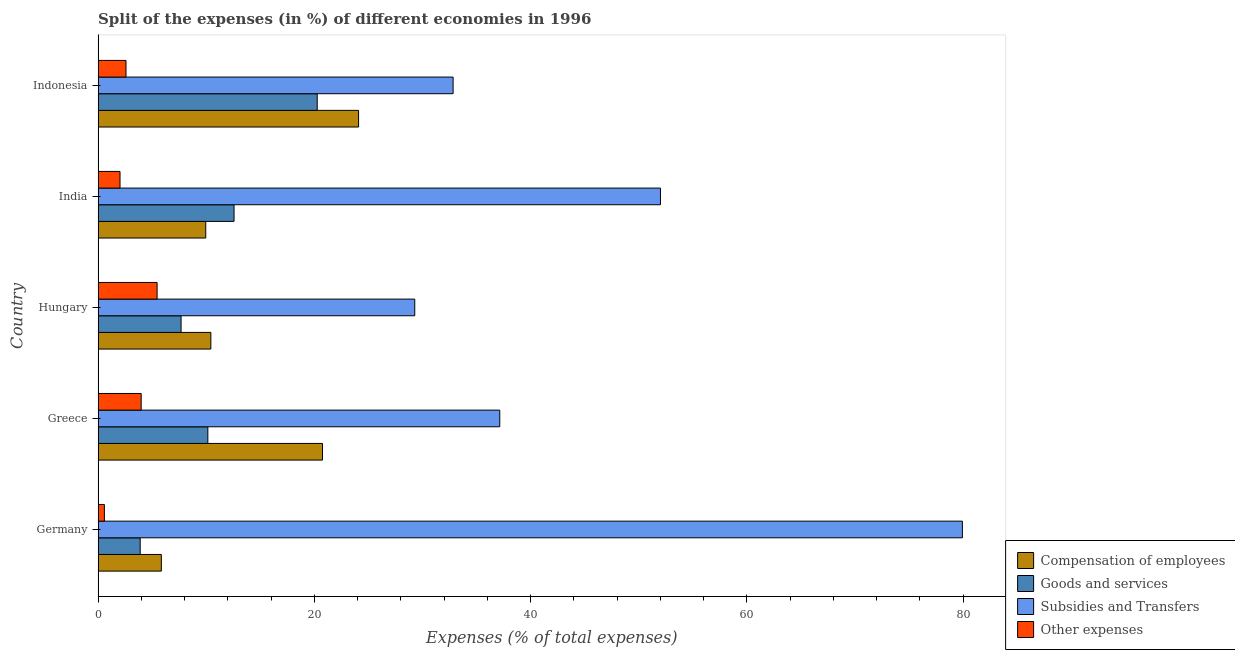Are the number of bars on each tick of the Y-axis equal?
Your response must be concise. Yes. How many bars are there on the 1st tick from the top?
Your answer should be very brief. 4. How many bars are there on the 3rd tick from the bottom?
Keep it short and to the point. 4. What is the percentage of amount spent on other expenses in Indonesia?
Offer a very short reply. 2.58. Across all countries, what is the maximum percentage of amount spent on other expenses?
Offer a terse response. 5.45. Across all countries, what is the minimum percentage of amount spent on subsidies?
Give a very brief answer. 29.28. What is the total percentage of amount spent on compensation of employees in the graph?
Give a very brief answer. 71.07. What is the difference between the percentage of amount spent on other expenses in Germany and that in Indonesia?
Your answer should be very brief. -2. What is the difference between the percentage of amount spent on other expenses in Germany and the percentage of amount spent on compensation of employees in India?
Offer a terse response. -9.37. What is the average percentage of amount spent on other expenses per country?
Offer a terse response. 2.92. What is the difference between the percentage of amount spent on subsidies and percentage of amount spent on other expenses in India?
Ensure brevity in your answer.  49.98. What is the ratio of the percentage of amount spent on goods and services in Hungary to that in India?
Provide a short and direct response. 0.61. Is the percentage of amount spent on goods and services in Greece less than that in Hungary?
Offer a terse response. No. What is the difference between the highest and the second highest percentage of amount spent on compensation of employees?
Offer a terse response. 3.34. What is the difference between the highest and the lowest percentage of amount spent on subsidies?
Your response must be concise. 50.65. In how many countries, is the percentage of amount spent on compensation of employees greater than the average percentage of amount spent on compensation of employees taken over all countries?
Keep it short and to the point. 2. Is the sum of the percentage of amount spent on goods and services in Greece and India greater than the maximum percentage of amount spent on compensation of employees across all countries?
Make the answer very short. No. Is it the case that in every country, the sum of the percentage of amount spent on other expenses and percentage of amount spent on goods and services is greater than the sum of percentage of amount spent on compensation of employees and percentage of amount spent on subsidies?
Offer a very short reply. No. What does the 2nd bar from the top in Germany represents?
Provide a succinct answer. Subsidies and Transfers. What does the 1st bar from the bottom in Germany represents?
Keep it short and to the point. Compensation of employees. Is it the case that in every country, the sum of the percentage of amount spent on compensation of employees and percentage of amount spent on goods and services is greater than the percentage of amount spent on subsidies?
Give a very brief answer. No. How many bars are there?
Ensure brevity in your answer.  20. Are all the bars in the graph horizontal?
Provide a succinct answer. Yes. How many countries are there in the graph?
Your response must be concise. 5. Where does the legend appear in the graph?
Offer a terse response. Bottom right. How many legend labels are there?
Ensure brevity in your answer.  4. How are the legend labels stacked?
Make the answer very short. Vertical. What is the title of the graph?
Offer a very short reply. Split of the expenses (in %) of different economies in 1996. What is the label or title of the X-axis?
Provide a succinct answer. Expenses (% of total expenses). What is the label or title of the Y-axis?
Ensure brevity in your answer.  Country. What is the Expenses (% of total expenses) in Compensation of employees in Germany?
Your response must be concise. 5.85. What is the Expenses (% of total expenses) in Goods and services in Germany?
Offer a terse response. 3.89. What is the Expenses (% of total expenses) in Subsidies and Transfers in Germany?
Your answer should be very brief. 79.93. What is the Expenses (% of total expenses) in Other expenses in Germany?
Offer a very short reply. 0.58. What is the Expenses (% of total expenses) in Compensation of employees in Greece?
Your response must be concise. 20.75. What is the Expenses (% of total expenses) of Goods and services in Greece?
Your response must be concise. 10.15. What is the Expenses (% of total expenses) of Subsidies and Transfers in Greece?
Your answer should be compact. 37.15. What is the Expenses (% of total expenses) in Other expenses in Greece?
Your answer should be very brief. 3.98. What is the Expenses (% of total expenses) of Compensation of employees in Hungary?
Offer a terse response. 10.43. What is the Expenses (% of total expenses) in Goods and services in Hungary?
Offer a very short reply. 7.67. What is the Expenses (% of total expenses) in Subsidies and Transfers in Hungary?
Make the answer very short. 29.28. What is the Expenses (% of total expenses) of Other expenses in Hungary?
Your response must be concise. 5.45. What is the Expenses (% of total expenses) in Compensation of employees in India?
Your response must be concise. 9.95. What is the Expenses (% of total expenses) in Goods and services in India?
Your answer should be compact. 12.57. What is the Expenses (% of total expenses) in Subsidies and Transfers in India?
Ensure brevity in your answer.  52.01. What is the Expenses (% of total expenses) in Other expenses in India?
Provide a succinct answer. 2.03. What is the Expenses (% of total expenses) of Compensation of employees in Indonesia?
Give a very brief answer. 24.09. What is the Expenses (% of total expenses) of Goods and services in Indonesia?
Your answer should be compact. 20.26. What is the Expenses (% of total expenses) in Subsidies and Transfers in Indonesia?
Provide a short and direct response. 32.83. What is the Expenses (% of total expenses) of Other expenses in Indonesia?
Offer a terse response. 2.58. Across all countries, what is the maximum Expenses (% of total expenses) of Compensation of employees?
Provide a succinct answer. 24.09. Across all countries, what is the maximum Expenses (% of total expenses) of Goods and services?
Provide a short and direct response. 20.26. Across all countries, what is the maximum Expenses (% of total expenses) of Subsidies and Transfers?
Make the answer very short. 79.93. Across all countries, what is the maximum Expenses (% of total expenses) in Other expenses?
Your answer should be very brief. 5.45. Across all countries, what is the minimum Expenses (% of total expenses) of Compensation of employees?
Provide a short and direct response. 5.85. Across all countries, what is the minimum Expenses (% of total expenses) in Goods and services?
Provide a succinct answer. 3.89. Across all countries, what is the minimum Expenses (% of total expenses) in Subsidies and Transfers?
Offer a very short reply. 29.28. Across all countries, what is the minimum Expenses (% of total expenses) of Other expenses?
Your answer should be compact. 0.58. What is the total Expenses (% of total expenses) of Compensation of employees in the graph?
Provide a succinct answer. 71.07. What is the total Expenses (% of total expenses) in Goods and services in the graph?
Your response must be concise. 54.55. What is the total Expenses (% of total expenses) of Subsidies and Transfers in the graph?
Make the answer very short. 231.2. What is the total Expenses (% of total expenses) of Other expenses in the graph?
Offer a very short reply. 14.62. What is the difference between the Expenses (% of total expenses) in Compensation of employees in Germany and that in Greece?
Make the answer very short. -14.9. What is the difference between the Expenses (% of total expenses) in Goods and services in Germany and that in Greece?
Offer a very short reply. -6.26. What is the difference between the Expenses (% of total expenses) of Subsidies and Transfers in Germany and that in Greece?
Your answer should be very brief. 42.79. What is the difference between the Expenses (% of total expenses) in Other expenses in Germany and that in Greece?
Provide a short and direct response. -3.4. What is the difference between the Expenses (% of total expenses) of Compensation of employees in Germany and that in Hungary?
Your answer should be very brief. -4.58. What is the difference between the Expenses (% of total expenses) of Goods and services in Germany and that in Hungary?
Your answer should be very brief. -3.78. What is the difference between the Expenses (% of total expenses) of Subsidies and Transfers in Germany and that in Hungary?
Keep it short and to the point. 50.65. What is the difference between the Expenses (% of total expenses) in Other expenses in Germany and that in Hungary?
Your response must be concise. -4.87. What is the difference between the Expenses (% of total expenses) of Compensation of employees in Germany and that in India?
Your answer should be compact. -4.11. What is the difference between the Expenses (% of total expenses) of Goods and services in Germany and that in India?
Your answer should be very brief. -8.68. What is the difference between the Expenses (% of total expenses) of Subsidies and Transfers in Germany and that in India?
Make the answer very short. 27.92. What is the difference between the Expenses (% of total expenses) in Other expenses in Germany and that in India?
Your response must be concise. -1.45. What is the difference between the Expenses (% of total expenses) of Compensation of employees in Germany and that in Indonesia?
Ensure brevity in your answer.  -18.24. What is the difference between the Expenses (% of total expenses) of Goods and services in Germany and that in Indonesia?
Make the answer very short. -16.37. What is the difference between the Expenses (% of total expenses) in Subsidies and Transfers in Germany and that in Indonesia?
Make the answer very short. 47.1. What is the difference between the Expenses (% of total expenses) in Other expenses in Germany and that in Indonesia?
Provide a succinct answer. -2. What is the difference between the Expenses (% of total expenses) of Compensation of employees in Greece and that in Hungary?
Offer a very short reply. 10.33. What is the difference between the Expenses (% of total expenses) of Goods and services in Greece and that in Hungary?
Provide a succinct answer. 2.48. What is the difference between the Expenses (% of total expenses) in Subsidies and Transfers in Greece and that in Hungary?
Keep it short and to the point. 7.86. What is the difference between the Expenses (% of total expenses) of Other expenses in Greece and that in Hungary?
Your answer should be very brief. -1.47. What is the difference between the Expenses (% of total expenses) of Compensation of employees in Greece and that in India?
Offer a very short reply. 10.8. What is the difference between the Expenses (% of total expenses) of Goods and services in Greece and that in India?
Offer a terse response. -2.42. What is the difference between the Expenses (% of total expenses) of Subsidies and Transfers in Greece and that in India?
Give a very brief answer. -14.86. What is the difference between the Expenses (% of total expenses) of Other expenses in Greece and that in India?
Make the answer very short. 1.96. What is the difference between the Expenses (% of total expenses) in Compensation of employees in Greece and that in Indonesia?
Offer a very short reply. -3.34. What is the difference between the Expenses (% of total expenses) in Goods and services in Greece and that in Indonesia?
Provide a short and direct response. -10.11. What is the difference between the Expenses (% of total expenses) of Subsidies and Transfers in Greece and that in Indonesia?
Ensure brevity in your answer.  4.32. What is the difference between the Expenses (% of total expenses) of Other expenses in Greece and that in Indonesia?
Offer a very short reply. 1.4. What is the difference between the Expenses (% of total expenses) in Compensation of employees in Hungary and that in India?
Provide a succinct answer. 0.47. What is the difference between the Expenses (% of total expenses) of Goods and services in Hungary and that in India?
Your answer should be very brief. -4.9. What is the difference between the Expenses (% of total expenses) of Subsidies and Transfers in Hungary and that in India?
Your answer should be very brief. -22.72. What is the difference between the Expenses (% of total expenses) of Other expenses in Hungary and that in India?
Ensure brevity in your answer.  3.43. What is the difference between the Expenses (% of total expenses) of Compensation of employees in Hungary and that in Indonesia?
Provide a short and direct response. -13.66. What is the difference between the Expenses (% of total expenses) in Goods and services in Hungary and that in Indonesia?
Offer a very short reply. -12.59. What is the difference between the Expenses (% of total expenses) of Subsidies and Transfers in Hungary and that in Indonesia?
Make the answer very short. -3.55. What is the difference between the Expenses (% of total expenses) in Other expenses in Hungary and that in Indonesia?
Give a very brief answer. 2.88. What is the difference between the Expenses (% of total expenses) in Compensation of employees in India and that in Indonesia?
Make the answer very short. -14.14. What is the difference between the Expenses (% of total expenses) of Goods and services in India and that in Indonesia?
Keep it short and to the point. -7.69. What is the difference between the Expenses (% of total expenses) of Subsidies and Transfers in India and that in Indonesia?
Make the answer very short. 19.18. What is the difference between the Expenses (% of total expenses) of Other expenses in India and that in Indonesia?
Ensure brevity in your answer.  -0.55. What is the difference between the Expenses (% of total expenses) in Compensation of employees in Germany and the Expenses (% of total expenses) in Goods and services in Greece?
Your answer should be very brief. -4.3. What is the difference between the Expenses (% of total expenses) of Compensation of employees in Germany and the Expenses (% of total expenses) of Subsidies and Transfers in Greece?
Ensure brevity in your answer.  -31.3. What is the difference between the Expenses (% of total expenses) of Compensation of employees in Germany and the Expenses (% of total expenses) of Other expenses in Greece?
Provide a short and direct response. 1.87. What is the difference between the Expenses (% of total expenses) in Goods and services in Germany and the Expenses (% of total expenses) in Subsidies and Transfers in Greece?
Provide a short and direct response. -33.26. What is the difference between the Expenses (% of total expenses) in Goods and services in Germany and the Expenses (% of total expenses) in Other expenses in Greece?
Make the answer very short. -0.09. What is the difference between the Expenses (% of total expenses) of Subsidies and Transfers in Germany and the Expenses (% of total expenses) of Other expenses in Greece?
Give a very brief answer. 75.95. What is the difference between the Expenses (% of total expenses) in Compensation of employees in Germany and the Expenses (% of total expenses) in Goods and services in Hungary?
Ensure brevity in your answer.  -1.82. What is the difference between the Expenses (% of total expenses) of Compensation of employees in Germany and the Expenses (% of total expenses) of Subsidies and Transfers in Hungary?
Offer a very short reply. -23.44. What is the difference between the Expenses (% of total expenses) in Compensation of employees in Germany and the Expenses (% of total expenses) in Other expenses in Hungary?
Provide a succinct answer. 0.39. What is the difference between the Expenses (% of total expenses) in Goods and services in Germany and the Expenses (% of total expenses) in Subsidies and Transfers in Hungary?
Make the answer very short. -25.39. What is the difference between the Expenses (% of total expenses) in Goods and services in Germany and the Expenses (% of total expenses) in Other expenses in Hungary?
Ensure brevity in your answer.  -1.56. What is the difference between the Expenses (% of total expenses) of Subsidies and Transfers in Germany and the Expenses (% of total expenses) of Other expenses in Hungary?
Provide a short and direct response. 74.48. What is the difference between the Expenses (% of total expenses) of Compensation of employees in Germany and the Expenses (% of total expenses) of Goods and services in India?
Ensure brevity in your answer.  -6.72. What is the difference between the Expenses (% of total expenses) in Compensation of employees in Germany and the Expenses (% of total expenses) in Subsidies and Transfers in India?
Your answer should be compact. -46.16. What is the difference between the Expenses (% of total expenses) of Compensation of employees in Germany and the Expenses (% of total expenses) of Other expenses in India?
Your answer should be compact. 3.82. What is the difference between the Expenses (% of total expenses) in Goods and services in Germany and the Expenses (% of total expenses) in Subsidies and Transfers in India?
Provide a succinct answer. -48.12. What is the difference between the Expenses (% of total expenses) of Goods and services in Germany and the Expenses (% of total expenses) of Other expenses in India?
Your answer should be very brief. 1.87. What is the difference between the Expenses (% of total expenses) of Subsidies and Transfers in Germany and the Expenses (% of total expenses) of Other expenses in India?
Your response must be concise. 77.91. What is the difference between the Expenses (% of total expenses) in Compensation of employees in Germany and the Expenses (% of total expenses) in Goods and services in Indonesia?
Offer a very short reply. -14.41. What is the difference between the Expenses (% of total expenses) of Compensation of employees in Germany and the Expenses (% of total expenses) of Subsidies and Transfers in Indonesia?
Your response must be concise. -26.98. What is the difference between the Expenses (% of total expenses) of Compensation of employees in Germany and the Expenses (% of total expenses) of Other expenses in Indonesia?
Ensure brevity in your answer.  3.27. What is the difference between the Expenses (% of total expenses) in Goods and services in Germany and the Expenses (% of total expenses) in Subsidies and Transfers in Indonesia?
Provide a succinct answer. -28.94. What is the difference between the Expenses (% of total expenses) in Goods and services in Germany and the Expenses (% of total expenses) in Other expenses in Indonesia?
Offer a terse response. 1.31. What is the difference between the Expenses (% of total expenses) of Subsidies and Transfers in Germany and the Expenses (% of total expenses) of Other expenses in Indonesia?
Ensure brevity in your answer.  77.35. What is the difference between the Expenses (% of total expenses) of Compensation of employees in Greece and the Expenses (% of total expenses) of Goods and services in Hungary?
Make the answer very short. 13.08. What is the difference between the Expenses (% of total expenses) of Compensation of employees in Greece and the Expenses (% of total expenses) of Subsidies and Transfers in Hungary?
Make the answer very short. -8.53. What is the difference between the Expenses (% of total expenses) in Compensation of employees in Greece and the Expenses (% of total expenses) in Other expenses in Hungary?
Your answer should be very brief. 15.3. What is the difference between the Expenses (% of total expenses) in Goods and services in Greece and the Expenses (% of total expenses) in Subsidies and Transfers in Hungary?
Provide a succinct answer. -19.14. What is the difference between the Expenses (% of total expenses) of Goods and services in Greece and the Expenses (% of total expenses) of Other expenses in Hungary?
Provide a succinct answer. 4.69. What is the difference between the Expenses (% of total expenses) in Subsidies and Transfers in Greece and the Expenses (% of total expenses) in Other expenses in Hungary?
Make the answer very short. 31.69. What is the difference between the Expenses (% of total expenses) of Compensation of employees in Greece and the Expenses (% of total expenses) of Goods and services in India?
Offer a terse response. 8.18. What is the difference between the Expenses (% of total expenses) in Compensation of employees in Greece and the Expenses (% of total expenses) in Subsidies and Transfers in India?
Keep it short and to the point. -31.26. What is the difference between the Expenses (% of total expenses) in Compensation of employees in Greece and the Expenses (% of total expenses) in Other expenses in India?
Give a very brief answer. 18.73. What is the difference between the Expenses (% of total expenses) in Goods and services in Greece and the Expenses (% of total expenses) in Subsidies and Transfers in India?
Offer a terse response. -41.86. What is the difference between the Expenses (% of total expenses) in Goods and services in Greece and the Expenses (% of total expenses) in Other expenses in India?
Your answer should be compact. 8.12. What is the difference between the Expenses (% of total expenses) of Subsidies and Transfers in Greece and the Expenses (% of total expenses) of Other expenses in India?
Make the answer very short. 35.12. What is the difference between the Expenses (% of total expenses) in Compensation of employees in Greece and the Expenses (% of total expenses) in Goods and services in Indonesia?
Your answer should be compact. 0.49. What is the difference between the Expenses (% of total expenses) in Compensation of employees in Greece and the Expenses (% of total expenses) in Subsidies and Transfers in Indonesia?
Your response must be concise. -12.08. What is the difference between the Expenses (% of total expenses) of Compensation of employees in Greece and the Expenses (% of total expenses) of Other expenses in Indonesia?
Keep it short and to the point. 18.17. What is the difference between the Expenses (% of total expenses) of Goods and services in Greece and the Expenses (% of total expenses) of Subsidies and Transfers in Indonesia?
Provide a short and direct response. -22.68. What is the difference between the Expenses (% of total expenses) in Goods and services in Greece and the Expenses (% of total expenses) in Other expenses in Indonesia?
Make the answer very short. 7.57. What is the difference between the Expenses (% of total expenses) in Subsidies and Transfers in Greece and the Expenses (% of total expenses) in Other expenses in Indonesia?
Keep it short and to the point. 34.57. What is the difference between the Expenses (% of total expenses) of Compensation of employees in Hungary and the Expenses (% of total expenses) of Goods and services in India?
Provide a succinct answer. -2.15. What is the difference between the Expenses (% of total expenses) of Compensation of employees in Hungary and the Expenses (% of total expenses) of Subsidies and Transfers in India?
Your response must be concise. -41.58. What is the difference between the Expenses (% of total expenses) of Compensation of employees in Hungary and the Expenses (% of total expenses) of Other expenses in India?
Your response must be concise. 8.4. What is the difference between the Expenses (% of total expenses) of Goods and services in Hungary and the Expenses (% of total expenses) of Subsidies and Transfers in India?
Provide a short and direct response. -44.34. What is the difference between the Expenses (% of total expenses) in Goods and services in Hungary and the Expenses (% of total expenses) in Other expenses in India?
Your response must be concise. 5.65. What is the difference between the Expenses (% of total expenses) in Subsidies and Transfers in Hungary and the Expenses (% of total expenses) in Other expenses in India?
Your answer should be very brief. 27.26. What is the difference between the Expenses (% of total expenses) in Compensation of employees in Hungary and the Expenses (% of total expenses) in Goods and services in Indonesia?
Make the answer very short. -9.84. What is the difference between the Expenses (% of total expenses) in Compensation of employees in Hungary and the Expenses (% of total expenses) in Subsidies and Transfers in Indonesia?
Ensure brevity in your answer.  -22.41. What is the difference between the Expenses (% of total expenses) in Compensation of employees in Hungary and the Expenses (% of total expenses) in Other expenses in Indonesia?
Keep it short and to the point. 7.85. What is the difference between the Expenses (% of total expenses) in Goods and services in Hungary and the Expenses (% of total expenses) in Subsidies and Transfers in Indonesia?
Your response must be concise. -25.16. What is the difference between the Expenses (% of total expenses) of Goods and services in Hungary and the Expenses (% of total expenses) of Other expenses in Indonesia?
Keep it short and to the point. 5.09. What is the difference between the Expenses (% of total expenses) of Subsidies and Transfers in Hungary and the Expenses (% of total expenses) of Other expenses in Indonesia?
Provide a short and direct response. 26.7. What is the difference between the Expenses (% of total expenses) of Compensation of employees in India and the Expenses (% of total expenses) of Goods and services in Indonesia?
Ensure brevity in your answer.  -10.31. What is the difference between the Expenses (% of total expenses) of Compensation of employees in India and the Expenses (% of total expenses) of Subsidies and Transfers in Indonesia?
Provide a succinct answer. -22.88. What is the difference between the Expenses (% of total expenses) of Compensation of employees in India and the Expenses (% of total expenses) of Other expenses in Indonesia?
Ensure brevity in your answer.  7.37. What is the difference between the Expenses (% of total expenses) in Goods and services in India and the Expenses (% of total expenses) in Subsidies and Transfers in Indonesia?
Keep it short and to the point. -20.26. What is the difference between the Expenses (% of total expenses) in Goods and services in India and the Expenses (% of total expenses) in Other expenses in Indonesia?
Your response must be concise. 9.99. What is the difference between the Expenses (% of total expenses) of Subsidies and Transfers in India and the Expenses (% of total expenses) of Other expenses in Indonesia?
Give a very brief answer. 49.43. What is the average Expenses (% of total expenses) in Compensation of employees per country?
Provide a succinct answer. 14.21. What is the average Expenses (% of total expenses) in Goods and services per country?
Provide a succinct answer. 10.91. What is the average Expenses (% of total expenses) of Subsidies and Transfers per country?
Offer a terse response. 46.24. What is the average Expenses (% of total expenses) of Other expenses per country?
Ensure brevity in your answer.  2.92. What is the difference between the Expenses (% of total expenses) of Compensation of employees and Expenses (% of total expenses) of Goods and services in Germany?
Provide a short and direct response. 1.96. What is the difference between the Expenses (% of total expenses) of Compensation of employees and Expenses (% of total expenses) of Subsidies and Transfers in Germany?
Give a very brief answer. -74.08. What is the difference between the Expenses (% of total expenses) in Compensation of employees and Expenses (% of total expenses) in Other expenses in Germany?
Your answer should be very brief. 5.27. What is the difference between the Expenses (% of total expenses) in Goods and services and Expenses (% of total expenses) in Subsidies and Transfers in Germany?
Offer a very short reply. -76.04. What is the difference between the Expenses (% of total expenses) in Goods and services and Expenses (% of total expenses) in Other expenses in Germany?
Offer a very short reply. 3.31. What is the difference between the Expenses (% of total expenses) in Subsidies and Transfers and Expenses (% of total expenses) in Other expenses in Germany?
Your response must be concise. 79.35. What is the difference between the Expenses (% of total expenses) of Compensation of employees and Expenses (% of total expenses) of Goods and services in Greece?
Offer a very short reply. 10.6. What is the difference between the Expenses (% of total expenses) of Compensation of employees and Expenses (% of total expenses) of Subsidies and Transfers in Greece?
Your answer should be compact. -16.39. What is the difference between the Expenses (% of total expenses) of Compensation of employees and Expenses (% of total expenses) of Other expenses in Greece?
Make the answer very short. 16.77. What is the difference between the Expenses (% of total expenses) of Goods and services and Expenses (% of total expenses) of Subsidies and Transfers in Greece?
Offer a very short reply. -27. What is the difference between the Expenses (% of total expenses) of Goods and services and Expenses (% of total expenses) of Other expenses in Greece?
Offer a very short reply. 6.17. What is the difference between the Expenses (% of total expenses) of Subsidies and Transfers and Expenses (% of total expenses) of Other expenses in Greece?
Your answer should be very brief. 33.16. What is the difference between the Expenses (% of total expenses) in Compensation of employees and Expenses (% of total expenses) in Goods and services in Hungary?
Provide a short and direct response. 2.75. What is the difference between the Expenses (% of total expenses) of Compensation of employees and Expenses (% of total expenses) of Subsidies and Transfers in Hungary?
Your answer should be very brief. -18.86. What is the difference between the Expenses (% of total expenses) of Compensation of employees and Expenses (% of total expenses) of Other expenses in Hungary?
Provide a succinct answer. 4.97. What is the difference between the Expenses (% of total expenses) of Goods and services and Expenses (% of total expenses) of Subsidies and Transfers in Hungary?
Your response must be concise. -21.61. What is the difference between the Expenses (% of total expenses) of Goods and services and Expenses (% of total expenses) of Other expenses in Hungary?
Your answer should be compact. 2.22. What is the difference between the Expenses (% of total expenses) in Subsidies and Transfers and Expenses (% of total expenses) in Other expenses in Hungary?
Ensure brevity in your answer.  23.83. What is the difference between the Expenses (% of total expenses) in Compensation of employees and Expenses (% of total expenses) in Goods and services in India?
Your answer should be compact. -2.62. What is the difference between the Expenses (% of total expenses) in Compensation of employees and Expenses (% of total expenses) in Subsidies and Transfers in India?
Your answer should be compact. -42.05. What is the difference between the Expenses (% of total expenses) in Compensation of employees and Expenses (% of total expenses) in Other expenses in India?
Your response must be concise. 7.93. What is the difference between the Expenses (% of total expenses) in Goods and services and Expenses (% of total expenses) in Subsidies and Transfers in India?
Your response must be concise. -39.44. What is the difference between the Expenses (% of total expenses) in Goods and services and Expenses (% of total expenses) in Other expenses in India?
Your answer should be very brief. 10.55. What is the difference between the Expenses (% of total expenses) in Subsidies and Transfers and Expenses (% of total expenses) in Other expenses in India?
Your answer should be compact. 49.98. What is the difference between the Expenses (% of total expenses) in Compensation of employees and Expenses (% of total expenses) in Goods and services in Indonesia?
Offer a terse response. 3.83. What is the difference between the Expenses (% of total expenses) in Compensation of employees and Expenses (% of total expenses) in Subsidies and Transfers in Indonesia?
Offer a terse response. -8.74. What is the difference between the Expenses (% of total expenses) in Compensation of employees and Expenses (% of total expenses) in Other expenses in Indonesia?
Provide a short and direct response. 21.51. What is the difference between the Expenses (% of total expenses) in Goods and services and Expenses (% of total expenses) in Subsidies and Transfers in Indonesia?
Your answer should be very brief. -12.57. What is the difference between the Expenses (% of total expenses) of Goods and services and Expenses (% of total expenses) of Other expenses in Indonesia?
Ensure brevity in your answer.  17.68. What is the difference between the Expenses (% of total expenses) in Subsidies and Transfers and Expenses (% of total expenses) in Other expenses in Indonesia?
Make the answer very short. 30.25. What is the ratio of the Expenses (% of total expenses) in Compensation of employees in Germany to that in Greece?
Your answer should be very brief. 0.28. What is the ratio of the Expenses (% of total expenses) of Goods and services in Germany to that in Greece?
Offer a terse response. 0.38. What is the ratio of the Expenses (% of total expenses) in Subsidies and Transfers in Germany to that in Greece?
Provide a short and direct response. 2.15. What is the ratio of the Expenses (% of total expenses) of Other expenses in Germany to that in Greece?
Give a very brief answer. 0.15. What is the ratio of the Expenses (% of total expenses) in Compensation of employees in Germany to that in Hungary?
Keep it short and to the point. 0.56. What is the ratio of the Expenses (% of total expenses) in Goods and services in Germany to that in Hungary?
Your response must be concise. 0.51. What is the ratio of the Expenses (% of total expenses) of Subsidies and Transfers in Germany to that in Hungary?
Give a very brief answer. 2.73. What is the ratio of the Expenses (% of total expenses) in Other expenses in Germany to that in Hungary?
Your answer should be compact. 0.11. What is the ratio of the Expenses (% of total expenses) of Compensation of employees in Germany to that in India?
Your response must be concise. 0.59. What is the ratio of the Expenses (% of total expenses) of Goods and services in Germany to that in India?
Ensure brevity in your answer.  0.31. What is the ratio of the Expenses (% of total expenses) of Subsidies and Transfers in Germany to that in India?
Give a very brief answer. 1.54. What is the ratio of the Expenses (% of total expenses) in Other expenses in Germany to that in India?
Provide a short and direct response. 0.29. What is the ratio of the Expenses (% of total expenses) of Compensation of employees in Germany to that in Indonesia?
Offer a very short reply. 0.24. What is the ratio of the Expenses (% of total expenses) in Goods and services in Germany to that in Indonesia?
Provide a short and direct response. 0.19. What is the ratio of the Expenses (% of total expenses) of Subsidies and Transfers in Germany to that in Indonesia?
Provide a succinct answer. 2.43. What is the ratio of the Expenses (% of total expenses) of Other expenses in Germany to that in Indonesia?
Your answer should be very brief. 0.22. What is the ratio of the Expenses (% of total expenses) of Compensation of employees in Greece to that in Hungary?
Give a very brief answer. 1.99. What is the ratio of the Expenses (% of total expenses) of Goods and services in Greece to that in Hungary?
Your answer should be compact. 1.32. What is the ratio of the Expenses (% of total expenses) of Subsidies and Transfers in Greece to that in Hungary?
Your response must be concise. 1.27. What is the ratio of the Expenses (% of total expenses) in Other expenses in Greece to that in Hungary?
Make the answer very short. 0.73. What is the ratio of the Expenses (% of total expenses) of Compensation of employees in Greece to that in India?
Your answer should be very brief. 2.08. What is the ratio of the Expenses (% of total expenses) of Goods and services in Greece to that in India?
Your response must be concise. 0.81. What is the ratio of the Expenses (% of total expenses) in Subsidies and Transfers in Greece to that in India?
Your answer should be very brief. 0.71. What is the ratio of the Expenses (% of total expenses) of Other expenses in Greece to that in India?
Ensure brevity in your answer.  1.97. What is the ratio of the Expenses (% of total expenses) of Compensation of employees in Greece to that in Indonesia?
Ensure brevity in your answer.  0.86. What is the ratio of the Expenses (% of total expenses) of Goods and services in Greece to that in Indonesia?
Make the answer very short. 0.5. What is the ratio of the Expenses (% of total expenses) in Subsidies and Transfers in Greece to that in Indonesia?
Offer a very short reply. 1.13. What is the ratio of the Expenses (% of total expenses) in Other expenses in Greece to that in Indonesia?
Your response must be concise. 1.54. What is the ratio of the Expenses (% of total expenses) of Compensation of employees in Hungary to that in India?
Your answer should be compact. 1.05. What is the ratio of the Expenses (% of total expenses) in Goods and services in Hungary to that in India?
Offer a very short reply. 0.61. What is the ratio of the Expenses (% of total expenses) of Subsidies and Transfers in Hungary to that in India?
Keep it short and to the point. 0.56. What is the ratio of the Expenses (% of total expenses) in Other expenses in Hungary to that in India?
Your answer should be very brief. 2.69. What is the ratio of the Expenses (% of total expenses) in Compensation of employees in Hungary to that in Indonesia?
Offer a terse response. 0.43. What is the ratio of the Expenses (% of total expenses) of Goods and services in Hungary to that in Indonesia?
Offer a very short reply. 0.38. What is the ratio of the Expenses (% of total expenses) of Subsidies and Transfers in Hungary to that in Indonesia?
Offer a terse response. 0.89. What is the ratio of the Expenses (% of total expenses) in Other expenses in Hungary to that in Indonesia?
Ensure brevity in your answer.  2.11. What is the ratio of the Expenses (% of total expenses) of Compensation of employees in India to that in Indonesia?
Your answer should be very brief. 0.41. What is the ratio of the Expenses (% of total expenses) of Goods and services in India to that in Indonesia?
Offer a very short reply. 0.62. What is the ratio of the Expenses (% of total expenses) of Subsidies and Transfers in India to that in Indonesia?
Offer a terse response. 1.58. What is the ratio of the Expenses (% of total expenses) of Other expenses in India to that in Indonesia?
Offer a terse response. 0.79. What is the difference between the highest and the second highest Expenses (% of total expenses) of Compensation of employees?
Provide a succinct answer. 3.34. What is the difference between the highest and the second highest Expenses (% of total expenses) in Goods and services?
Offer a very short reply. 7.69. What is the difference between the highest and the second highest Expenses (% of total expenses) of Subsidies and Transfers?
Provide a short and direct response. 27.92. What is the difference between the highest and the second highest Expenses (% of total expenses) in Other expenses?
Your answer should be very brief. 1.47. What is the difference between the highest and the lowest Expenses (% of total expenses) of Compensation of employees?
Provide a short and direct response. 18.24. What is the difference between the highest and the lowest Expenses (% of total expenses) of Goods and services?
Your answer should be compact. 16.37. What is the difference between the highest and the lowest Expenses (% of total expenses) of Subsidies and Transfers?
Offer a terse response. 50.65. What is the difference between the highest and the lowest Expenses (% of total expenses) in Other expenses?
Provide a succinct answer. 4.87. 